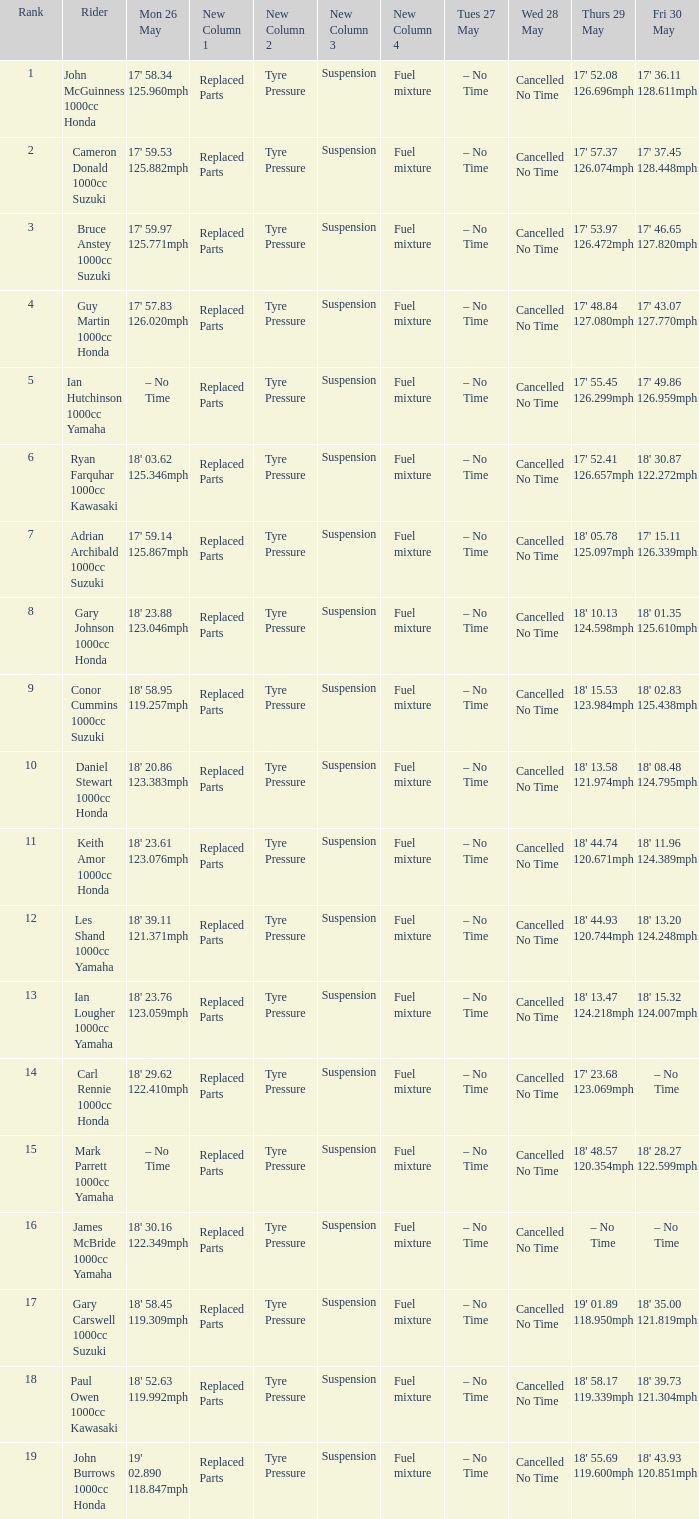What is the numbr for fri may 30 and mon may 26 is 19' 02.890 118.847mph? 18' 43.93 120.851mph. 